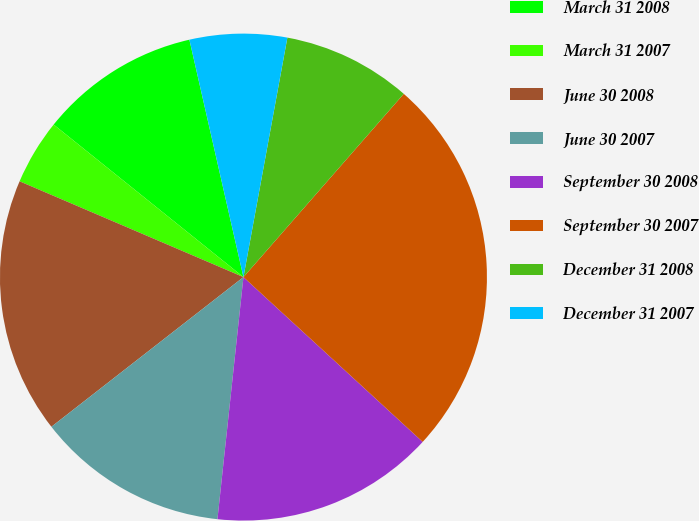Convert chart. <chart><loc_0><loc_0><loc_500><loc_500><pie_chart><fcel>March 31 2008<fcel>March 31 2007<fcel>June 30 2008<fcel>June 30 2007<fcel>September 30 2008<fcel>September 30 2007<fcel>December 31 2008<fcel>December 31 2007<nl><fcel>10.66%<fcel>4.34%<fcel>16.97%<fcel>12.76%<fcel>14.87%<fcel>25.39%<fcel>8.55%<fcel>6.45%<nl></chart> 